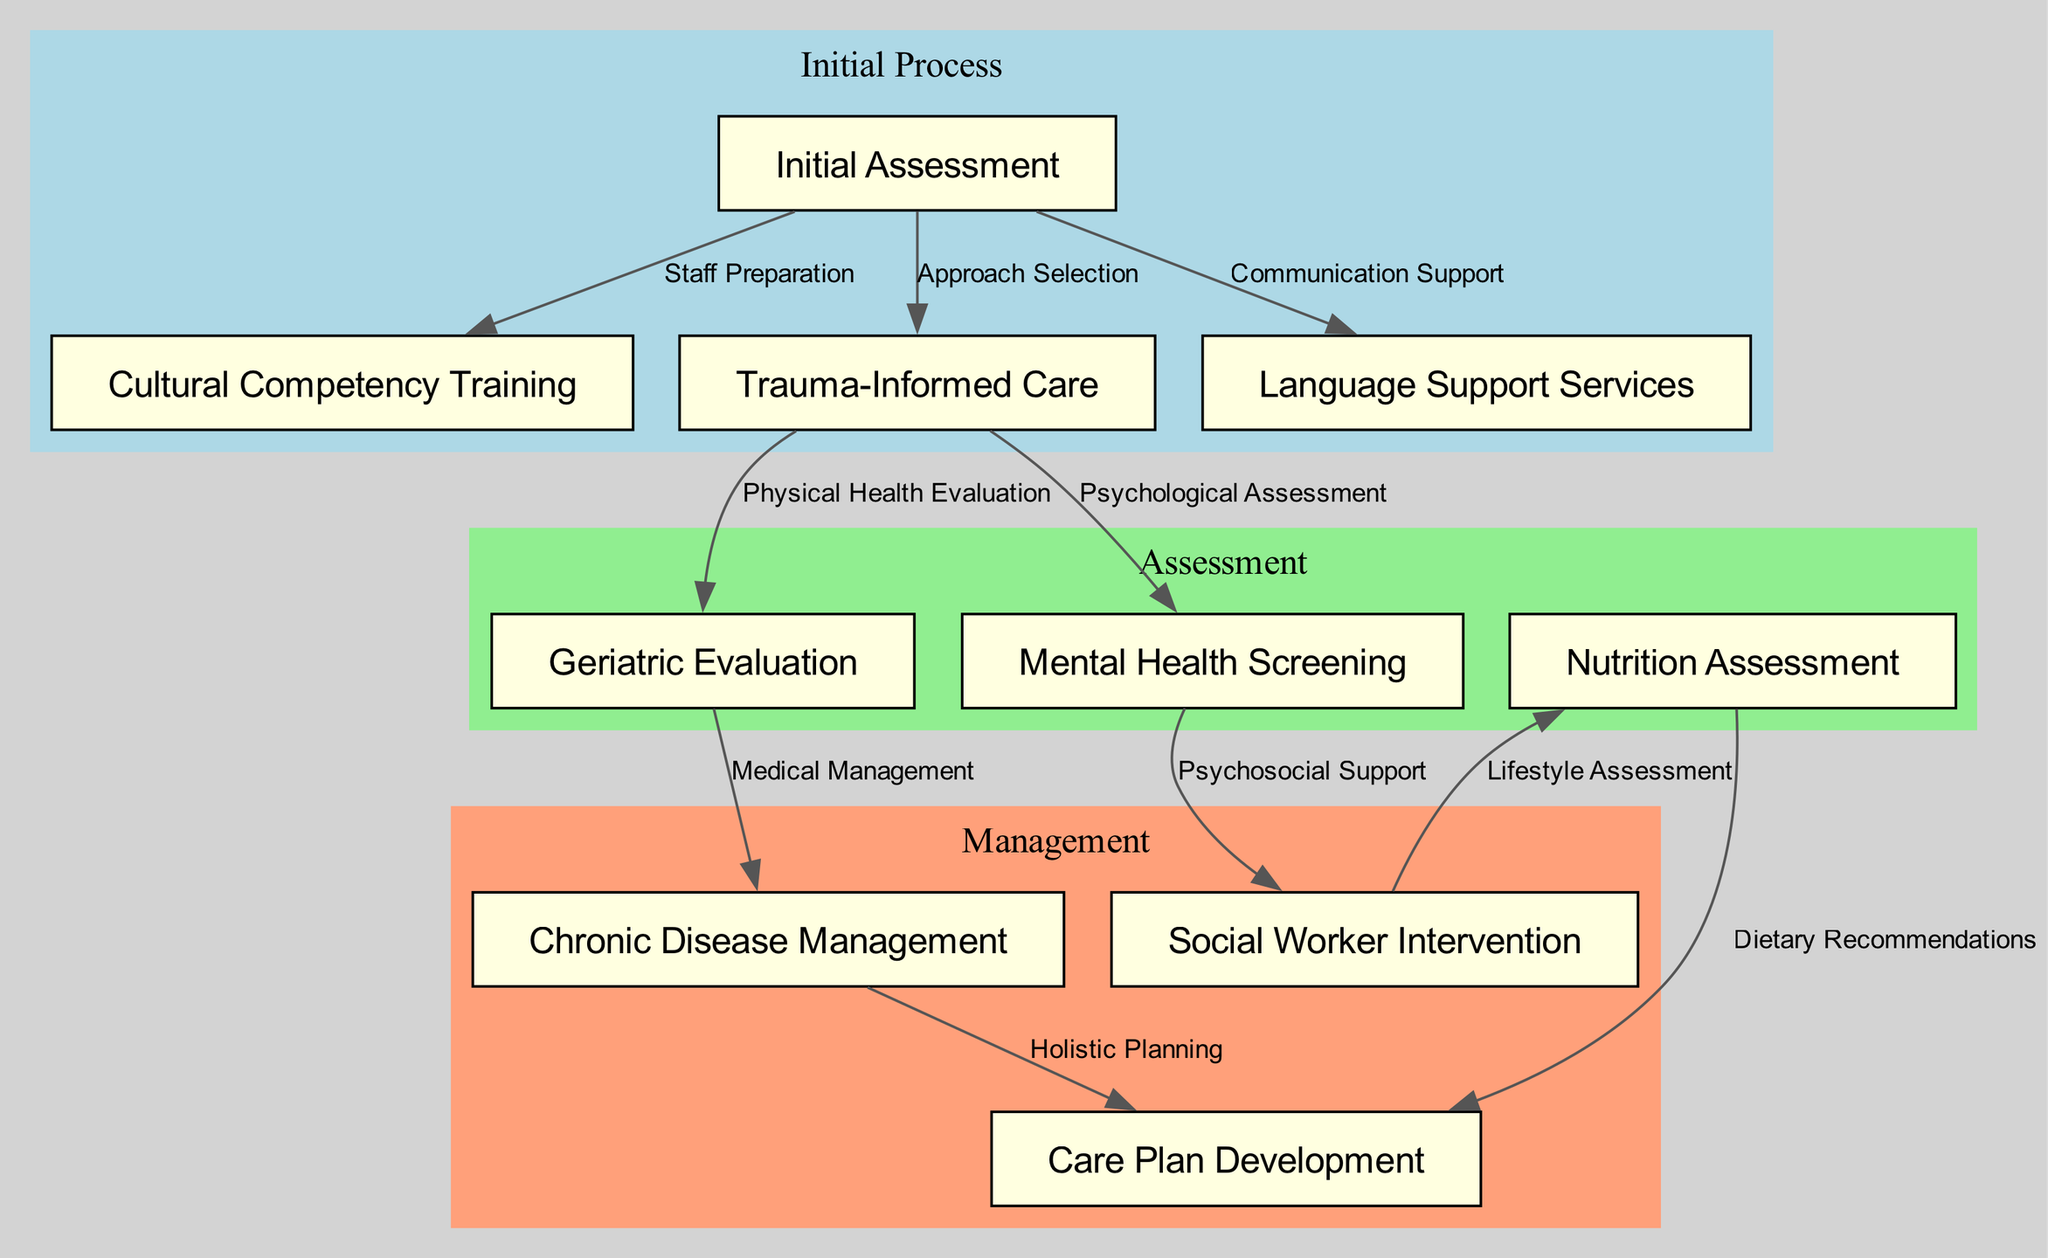What is the first step in the clinical pathway? The first step indicated in the diagram is "Initial Assessment." This is the starting point of the clinical pathway for elderly refugees, making it clear as the top node.
Answer: Initial Assessment How many nodes are in the diagram? To determine the total number of nodes, we can count each distinct label in the diagram. There are ten nodes listed in the data provided.
Answer: 10 Which node is linked to "Mental Health Screening"? "Mental Health Screening" is directly connected to the node "Social Worker Intervention" as indicated by the edge connecting them.
Answer: Social Worker Intervention What is the relationship between "Trauma-Informed Care" and "Geriatric Evaluation"? The relationship is described by the edge labeled "Physical Health Evaluation" that connects "Trauma-Informed Care" to "Geriatric Evaluation," showing a transition from trauma-informed practices to evaluation of physical health.
Answer: Physical Health Evaluation What does the "Social Worker Intervention" lead to in the pathway? "Social Worker Intervention" leads to "Lifestyle Assessment," as shown by the directed edge that connects the two nodes, indicating a step in the care process focusing on lifestyle.
Answer: Lifestyle Assessment Which step follows after "Chronic Disease Management"? After completing "Chronic Disease Management," the next step in the pathway is "Care Plan Development," according to the edge that connects these two nodes in the diagram.
Answer: Care Plan Development What type of training is necessary before the Initial Assessment? The diagram depicts "Cultural Competency Training" as necessary training, indicated by the edge labeled "Staff Preparation" leading from "Initial Assessment" to "Cultural Competency Training."
Answer: Cultural Competency Training What are the two assessments included in the assessment phase? The two assessments during the assessment phase are "Geriatric Evaluation" and "Mental Health Screening," as shown in the relevant cluster of nodes that fall under assessment.
Answer: Geriatric Evaluation and Mental Health Screening What support is provided for communication during the Initial Assessment? Communication support is provided through "Language Support Services," which is linked to the "Initial Assessment" in the diagram as denoted by the edge describing "Communication Support."
Answer: Language Support Services 